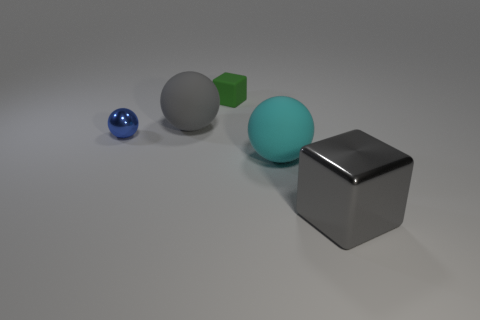Is the color of the small shiny thing the same as the large metallic cube?
Your answer should be compact. No. What number of shiny objects are either big blocks or tiny objects?
Provide a succinct answer. 2. How many big cyan rubber objects are there?
Offer a very short reply. 1. Is the material of the object to the left of the gray matte thing the same as the small object on the right side of the tiny sphere?
Make the answer very short. No. The other object that is the same shape as the gray metallic thing is what color?
Offer a terse response. Green. What is the material of the large gray thing behind the tiny blue metal sphere on the left side of the large metallic cube?
Make the answer very short. Rubber. Is the shape of the large thing that is to the right of the cyan matte ball the same as the tiny object that is to the right of the gray matte sphere?
Keep it short and to the point. Yes. What is the size of the thing that is in front of the small sphere and to the left of the big gray metallic block?
Give a very brief answer. Large. What number of other objects are there of the same color as the big metallic object?
Provide a short and direct response. 1. Does the gray object on the left side of the large metal thing have the same material as the small blue thing?
Provide a succinct answer. No. 